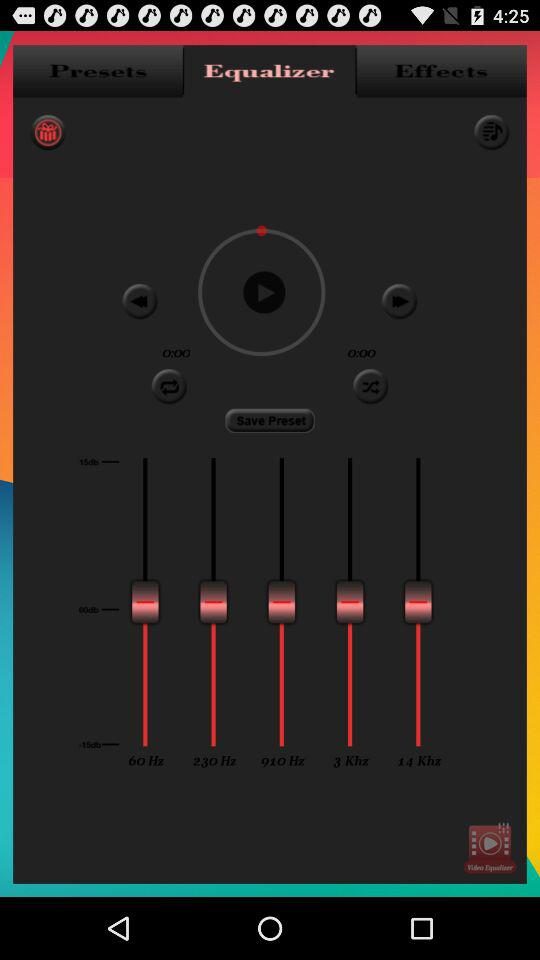How many frequencies does the equalizer have?
Answer the question using a single word or phrase. 5 